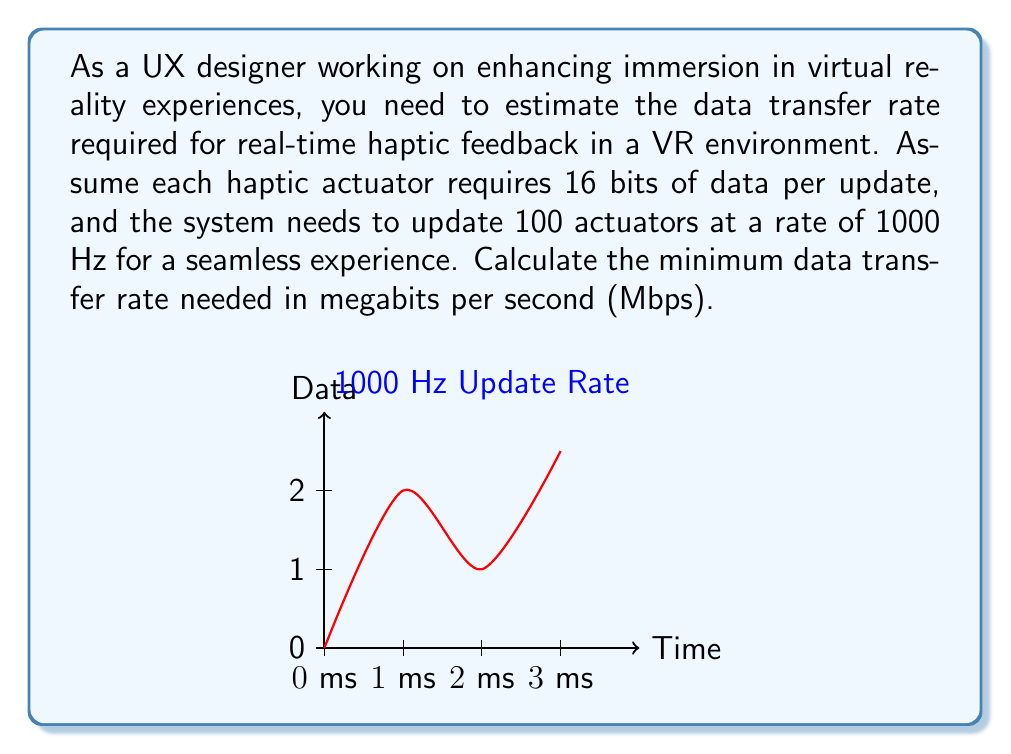Can you solve this math problem? To solve this problem, we'll follow these steps:

1. Calculate the total bits of data per update:
   $$ \text{Bits per update} = \text{Bits per actuator} \times \text{Number of actuators} $$
   $$ \text{Bits per update} = 16 \times 100 = 1600 \text{ bits} $$

2. Calculate the number of updates per second:
   $$ \text{Updates per second} = 1000 \text{ Hz} $$

3. Calculate the total bits per second:
   $$ \text{Bits per second} = \text{Bits per update} \times \text{Updates per second} $$
   $$ \text{Bits per second} = 1600 \times 1000 = 1,600,000 \text{ bps} $$

4. Convert bits per second to megabits per second:
   $$ \text{Mbps} = \frac{\text{Bits per second}}{1,000,000} $$
   $$ \text{Mbps} = \frac{1,600,000}{1,000,000} = 1.6 \text{ Mbps} $$

Therefore, the minimum data transfer rate needed for real-time haptic feedback in this VR environment is 1.6 Mbps.
Answer: 1.6 Mbps 